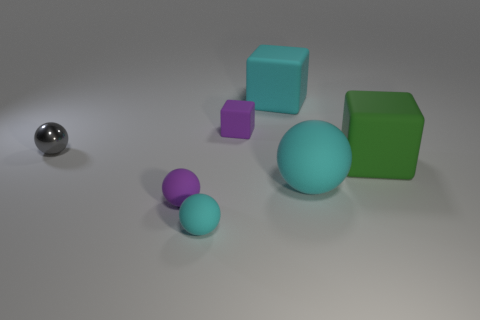There is a rubber block that is the same color as the big matte sphere; what size is it?
Give a very brief answer. Large. Is there any other thing that has the same material as the tiny gray object?
Ensure brevity in your answer.  No. Is there any other thing that has the same color as the tiny block?
Ensure brevity in your answer.  Yes. Does the small purple thing behind the gray shiny ball have the same material as the purple thing that is left of the small cyan thing?
Keep it short and to the point. Yes. What is the material of the small object that is the same shape as the big green object?
Offer a terse response. Rubber. Do the tiny block and the small gray thing have the same material?
Your answer should be compact. No. There is a tiny ball that is right of the purple object in front of the large rubber sphere; what color is it?
Provide a succinct answer. Cyan. The purple sphere that is the same material as the green thing is what size?
Give a very brief answer. Small. How many other rubber things are the same shape as the gray object?
Ensure brevity in your answer.  3. What number of things are things that are left of the green cube or large cyan rubber objects in front of the purple cube?
Provide a short and direct response. 6. 